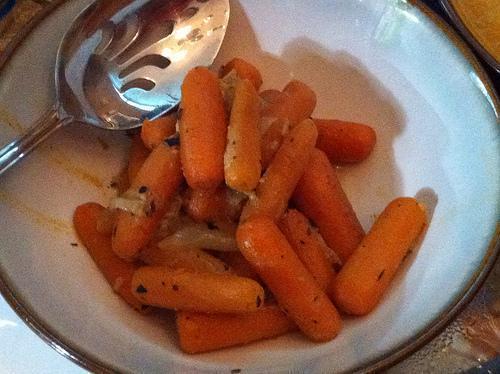How many spoons in the picture?
Give a very brief answer. 1. 